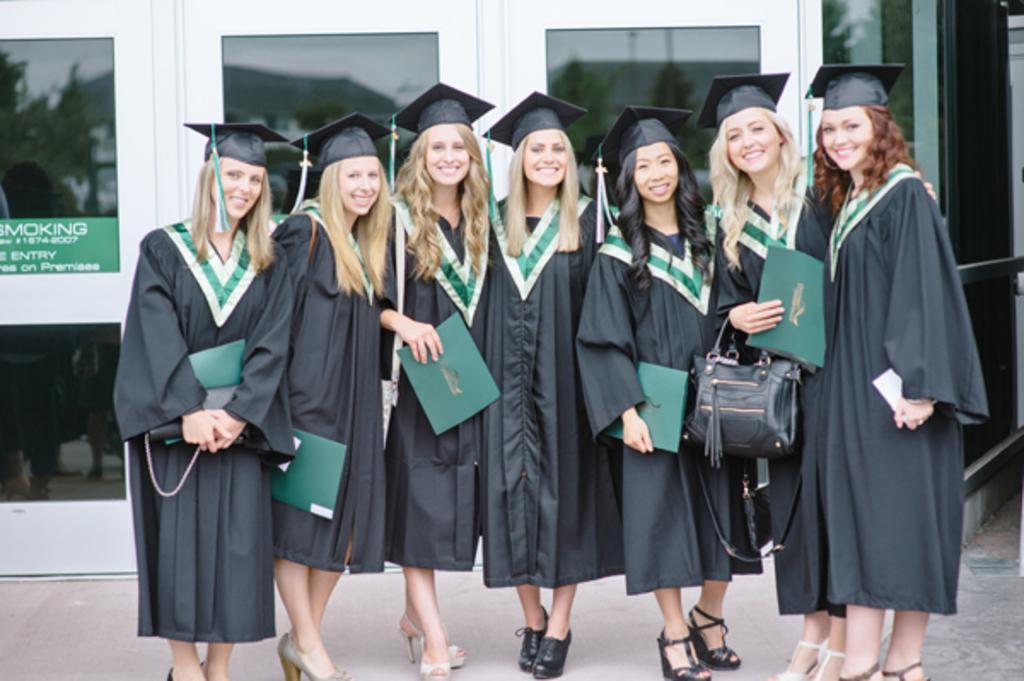In one or two sentences, can you explain what this image depicts? Here we can see few women are posing to a camera and they are smiling. In the background we can see glasses and a board. 